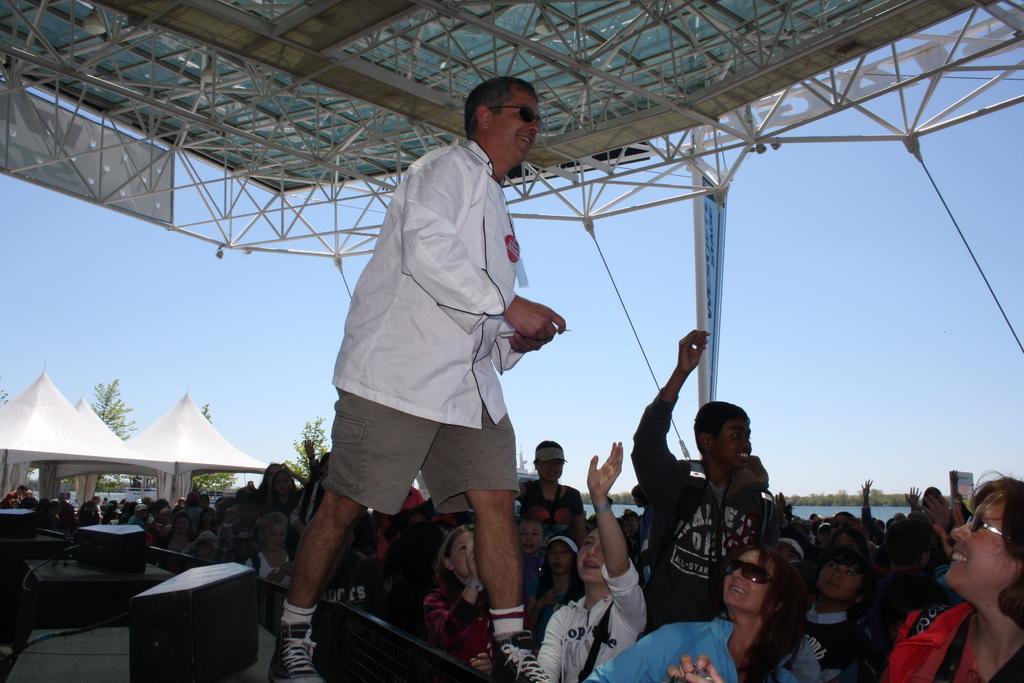In one or two sentences, can you explain what this image depicts? In this image I can see group of people standing and wearing different color dresses. I can see few speakers and one person is standing on the stage. Back I can see few tents,trees,shed,banner and water. The sky is in blue and white color. 